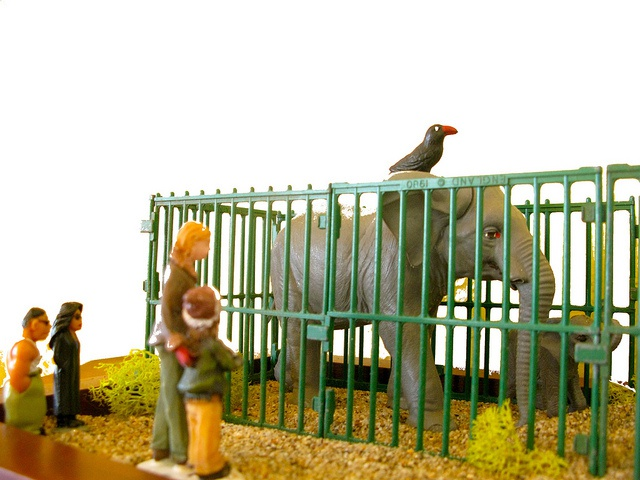Describe the objects in this image and their specific colors. I can see elephant in beige, darkgreen, gray, and tan tones, people in beige, olive, orange, and maroon tones, people in beige, olive, and maroon tones, people in beige, olive, red, and white tones, and bird in beige, black, gray, and darkgreen tones in this image. 